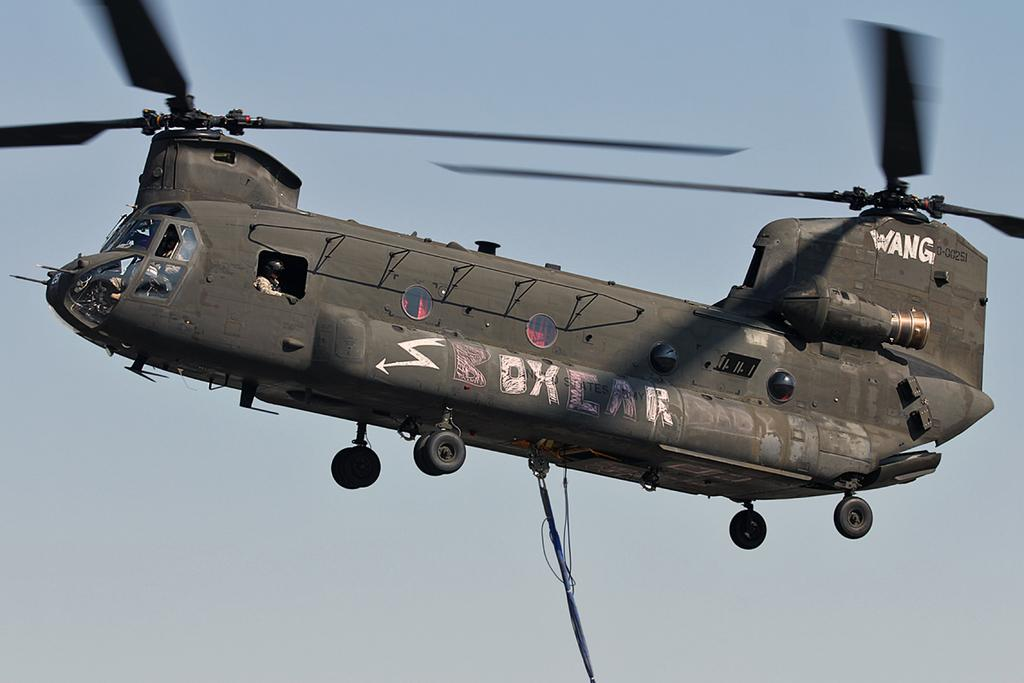<image>
Offer a succinct explanation of the picture presented. A grey Wang helicopter is soaring through the sky 